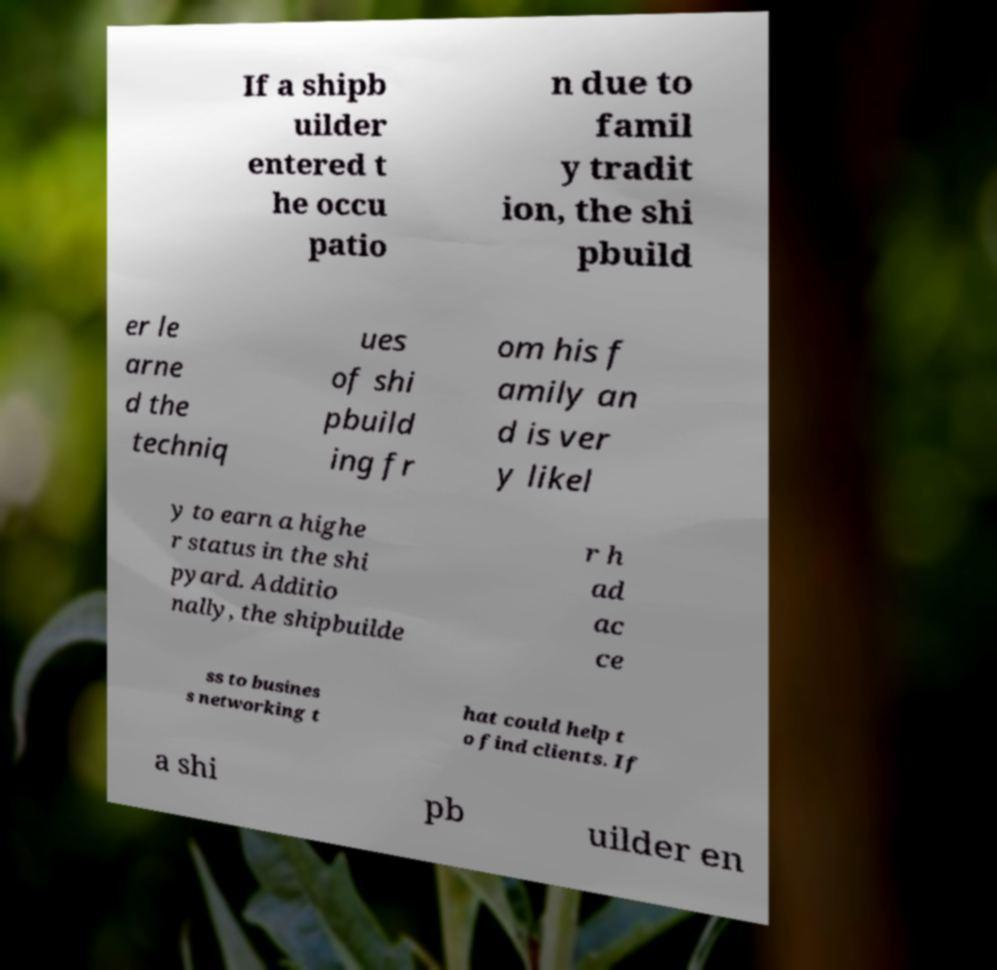Can you accurately transcribe the text from the provided image for me? If a shipb uilder entered t he occu patio n due to famil y tradit ion, the shi pbuild er le arne d the techniq ues of shi pbuild ing fr om his f amily an d is ver y likel y to earn a highe r status in the shi pyard. Additio nally, the shipbuilde r h ad ac ce ss to busines s networking t hat could help t o find clients. If a shi pb uilder en 